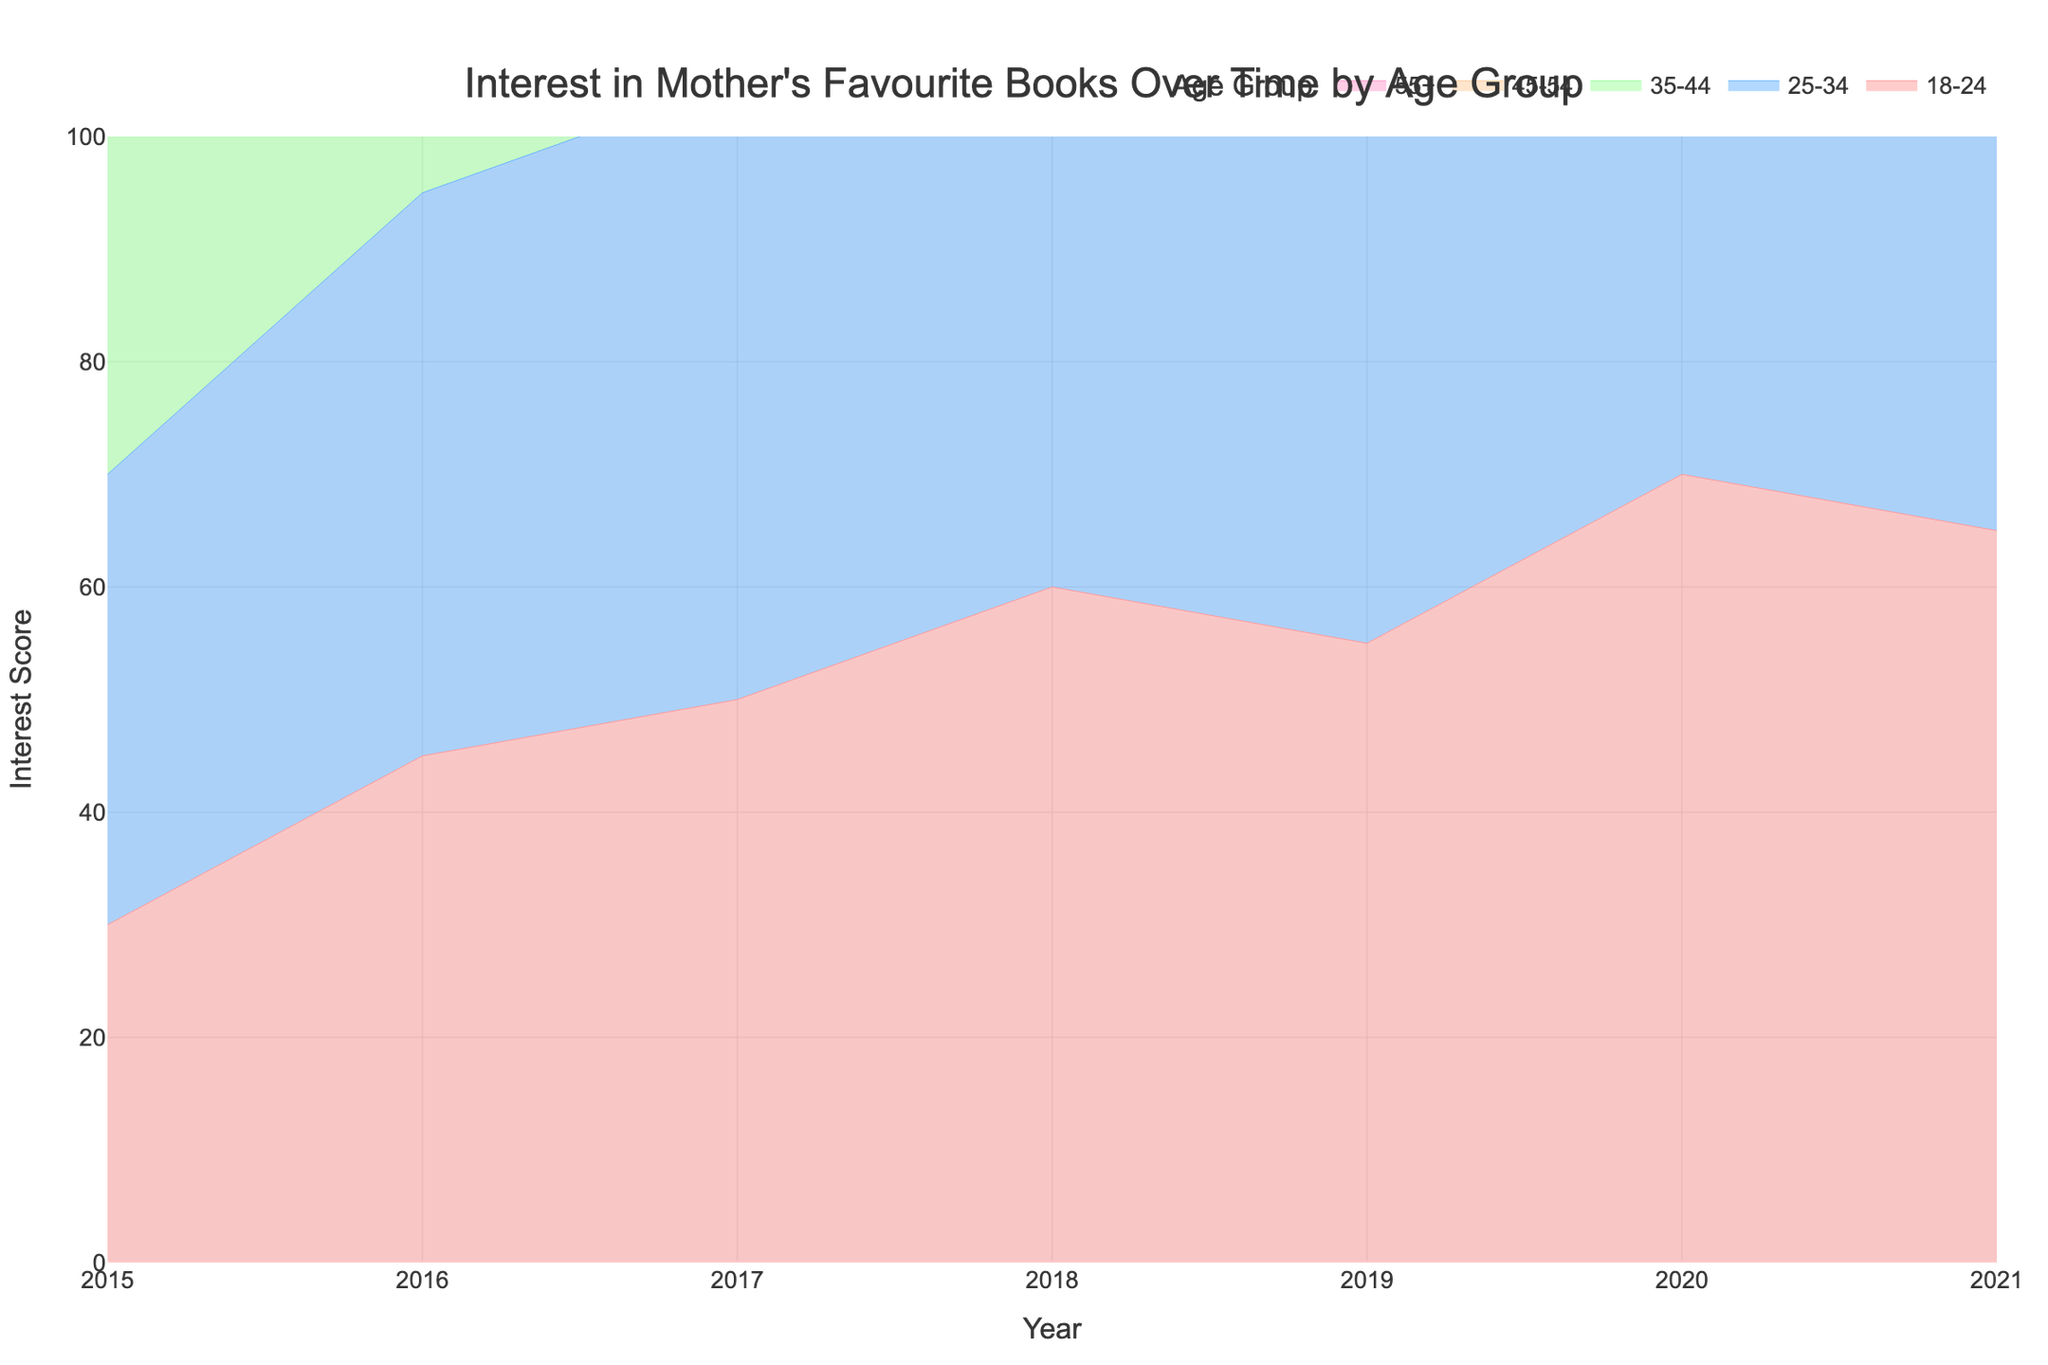What is the title of the figure? The figure's title is located at the top and provides a summary of what the chart represents.
Answer: "Interest in Mother's Favourite Books Over Time by Age Group" What is the interest score for the age group 25-34 in the year 2020? Locate the line for the 25-34 age group and look for the interest score value at the year 2020 on the x-axis.
Answer: 80 How does the interest score change for the age group 18-24 from 2015 to 2021? Compare the interest scores for the age group 18-24 at the years 2015 and 2021. The score increases from 30 (2015) to 65 (2021).
Answer: It increased Which age group has the highest interest score in 2021? Look at all the age groups' interest scores at the year 2021 and identify the highest.
Answer: 35-44 What is the range of interest scores in 2018 across all age groups? Identify the lowest and highest interest scores in 2018 and calculate the difference. The scores range from 45 (55+) to 75 (35-44). The range is 75 - 45 = 30.
Answer: 30 Which age group showed the largest increase in interest score between 2019 and 2020? Calculate the difference in interest scores between 2019 and 2020 for each age group. The age group 35-44 increased the most from 70 to 85, a difference of 15.
Answer: 35-44 What is the trend in interest scores for the age group 55+ from 2015 to 2021? Observe the change in scores for the age group 55+ over the given years. The trend shows a gradual increase each year.
Answer: Increasing Which two age groups have converging interest scores between 2019 and 2021? Compare the interest score trends for all age groups between 2019 and 2021. The age groups 45-54 and 55+ show scores that are becoming closer, converging towards 70-60 respectively in 2021.
Answer: 45-54 and 55+ In what year did the age group 25-34 have the same interest score as the age group 35-44 had in 2019? Notice the interest score for the 35-44 age group in 2019 (70) and look for the same score in the 25-34 age group. In 2020, the 25-34 group also had an interest score of 70.
Answer: 2020 